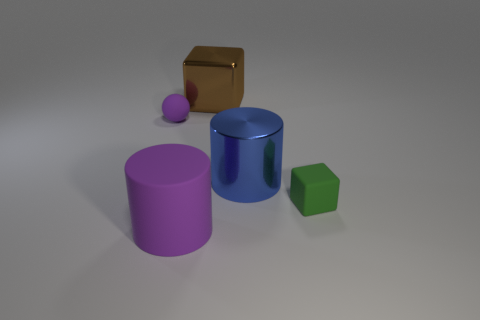Add 2 blue rubber spheres. How many objects exist? 7 Add 3 big cylinders. How many big cylinders exist? 5 Subtract 0 red cylinders. How many objects are left? 5 Subtract all cubes. How many objects are left? 3 Subtract all small purple balls. Subtract all cylinders. How many objects are left? 2 Add 3 small green cubes. How many small green cubes are left? 4 